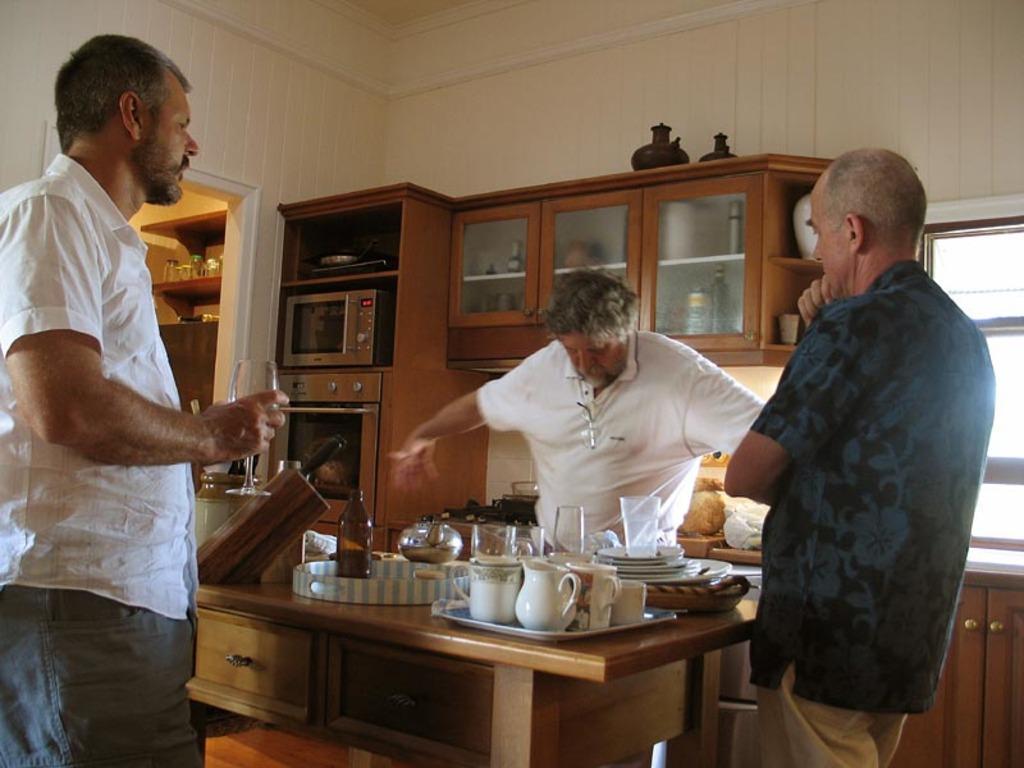Can you describe this image briefly? There are group of people standing and there are shelf at their back. 